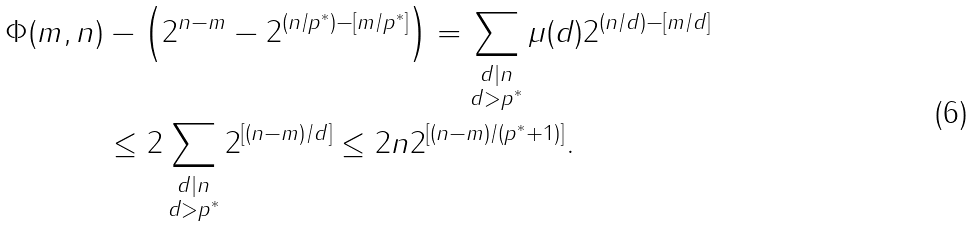Convert formula to latex. <formula><loc_0><loc_0><loc_500><loc_500>\Phi ( m , n ) & - \left ( 2 ^ { n - m } - 2 ^ { ( n / p ^ { \ast } ) - [ m / p ^ { \ast } ] } \right ) = \sum _ { \substack { d | n \\ d > { p ^ { \ast } } } } \mu ( d ) 2 ^ { ( n / d ) - [ m / d ] } \\ & \leq 2 \sum _ { \substack { d | n \\ d > { p ^ { \ast } } } } 2 ^ { [ ( n - m ) / d ] } \leq 2 n 2 ^ { [ ( n - m ) / ( { p ^ { \ast } } + 1 ) ] } .</formula> 